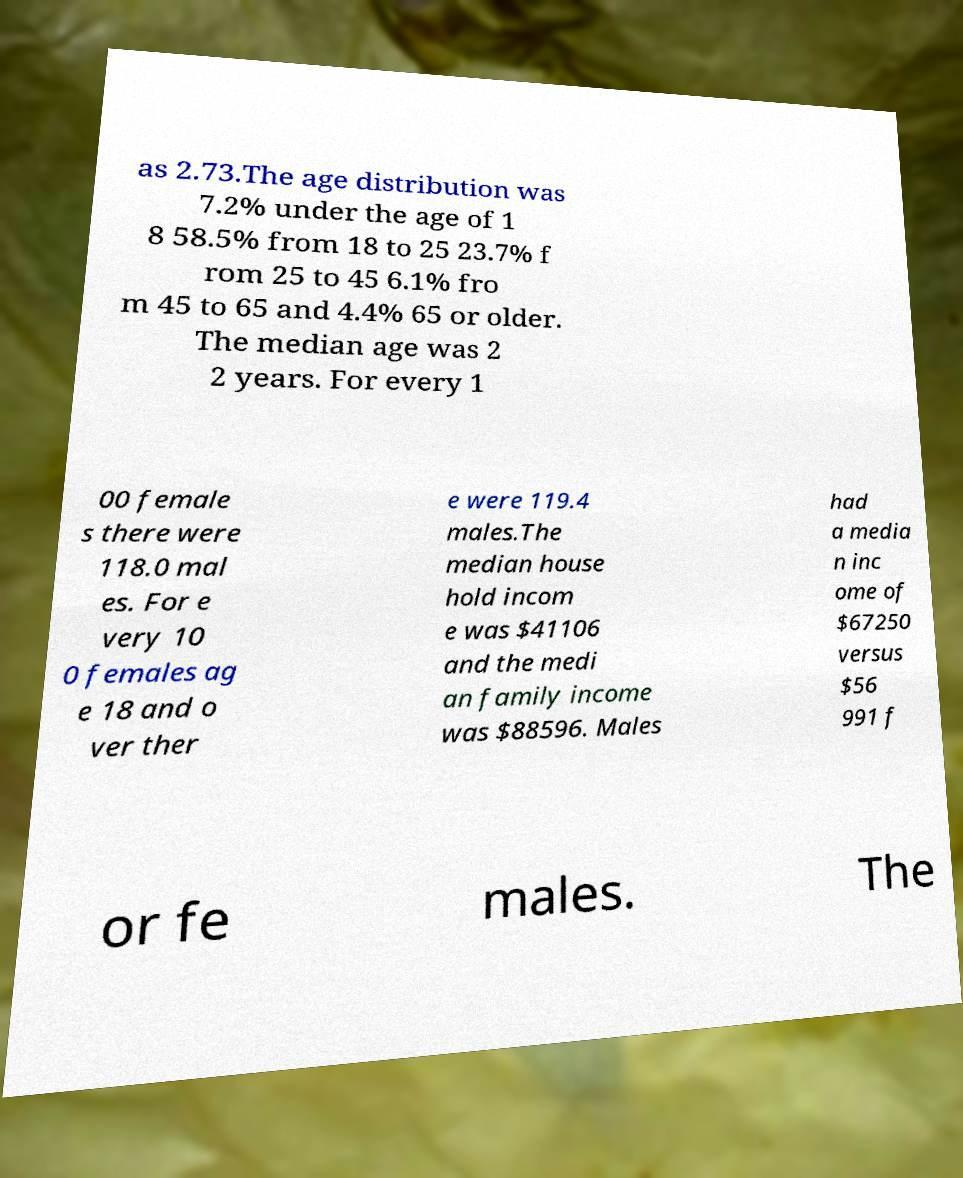What messages or text are displayed in this image? I need them in a readable, typed format. as 2.73.The age distribution was 7.2% under the age of 1 8 58.5% from 18 to 25 23.7% f rom 25 to 45 6.1% fro m 45 to 65 and 4.4% 65 or older. The median age was 2 2 years. For every 1 00 female s there were 118.0 mal es. For e very 10 0 females ag e 18 and o ver ther e were 119.4 males.The median house hold incom e was $41106 and the medi an family income was $88596. Males had a media n inc ome of $67250 versus $56 991 f or fe males. The 